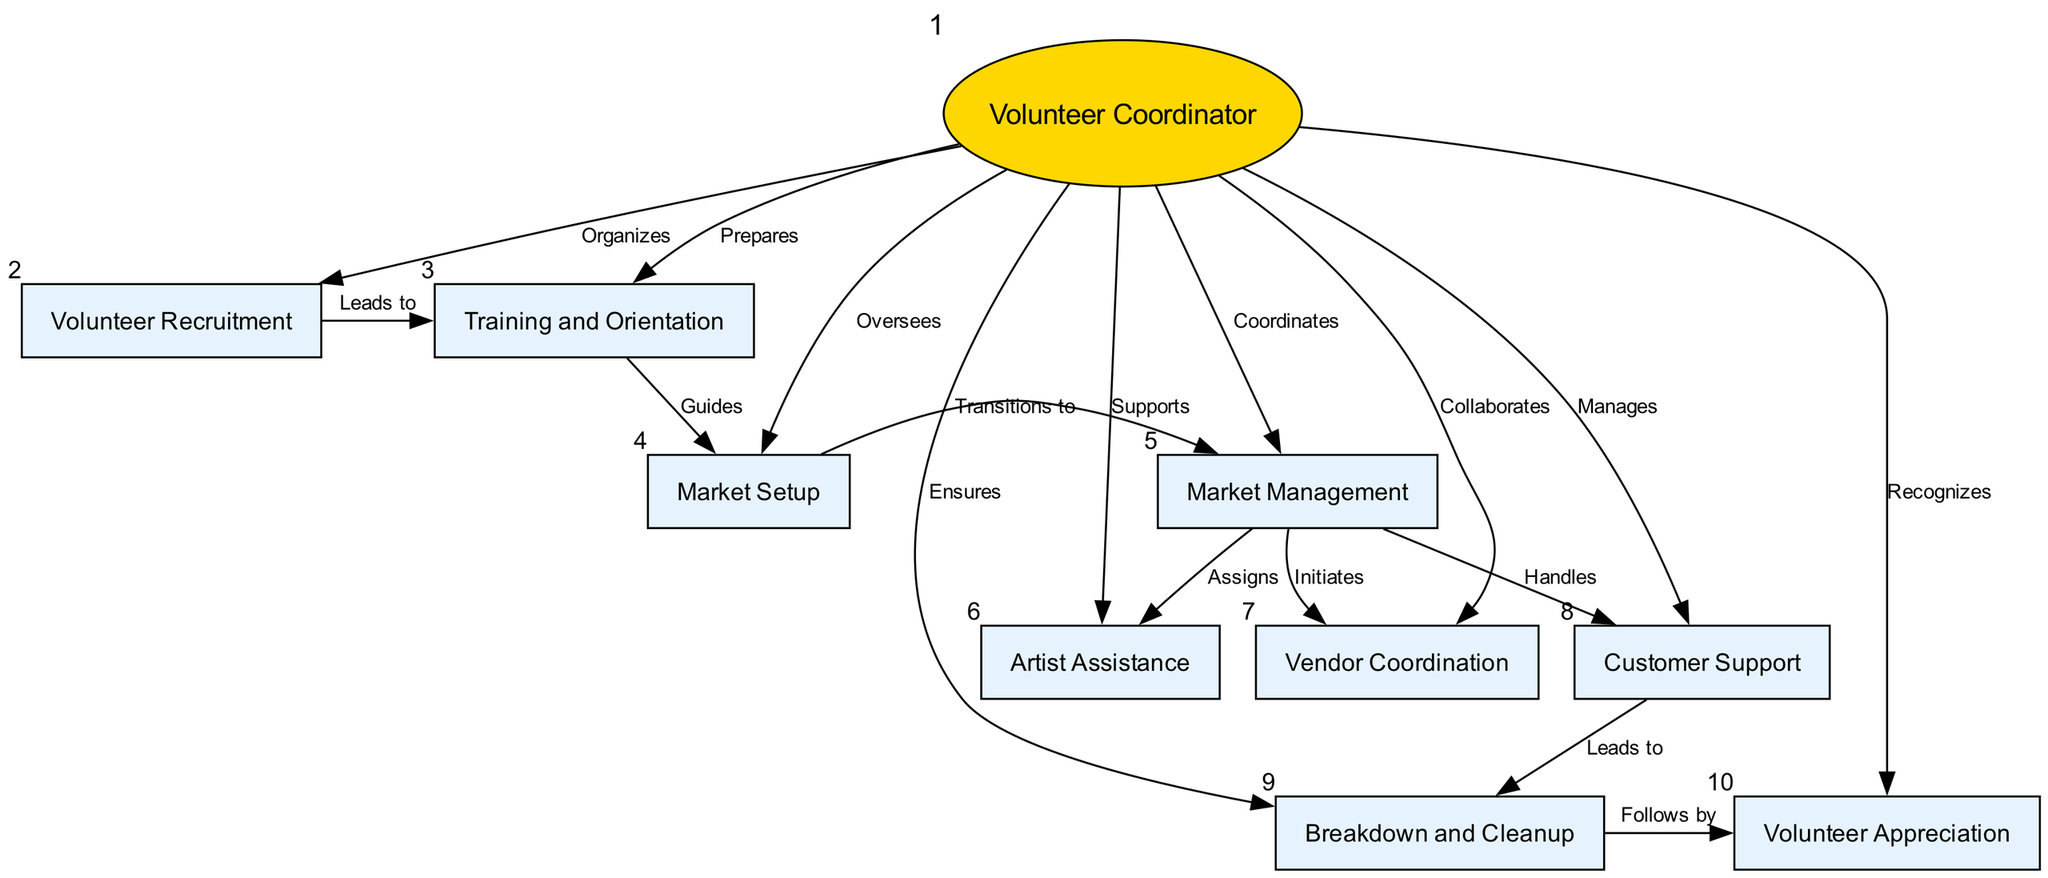What is the central node in the diagram? The central node is identified as the "Volunteer Coordinator" which is represented by a unique shape (ellipse) and highlighted differently from other nodes.
Answer: Volunteer Coordinator How many volunteer activities are listed in the diagram? By counting the nodes, there are ten volunteer activities represented in the diagram, which include both tasks and roles.
Answer: 10 Which activity is the Volunteer Coordinator responsible for overseeing? The "Market Setup" is directly linked to the Volunteer Coordinator with the edge labeled "Oversees," indicating their responsibility for this task.
Answer: Market Setup Which task follows "Customer Support" in the sequence? By following the directed flow from the "Customer Support" node, the next related node is "Breakdown and Cleanup," which is shown to be transitioned to by an edge labeled "Leads to."
Answer: Breakdown and Cleanup What does "Market Management" lead to in this diagram? The diagram shows that "Market Management" initiates three different activities based on the edges connected to it: "Artist Assistance," "Vendor Coordination," and "Customer Support."
Answer: Artist Assistance, Vendor Coordination, Customer Support How does "Volunteer Recruitment" relate to "Training and Orientation"? The diagram indicates a direct relationship where "Volunteer Recruitment" leads to "Training and Orientation," meaning that recruitment is the precursor to training.
Answer: Leads to What is a direct consequence of completing the "Breakdown and Cleanup"? The diagram indicates that after "Breakdown and Cleanup," the next step is "Volunteer Appreciation," connected by an edge labeled "Follows by."
Answer: Volunteer Appreciation What kind of support does the Volunteer Coordinator provide regarding artists? The relationship is shown as "Supports" which indicates the Volunteer Coordinator’s role in facilitating assistance for artists participating in the market.
Answer: Supports Which two activities come after "Market Setup"? Following the diagram's connections, "Market Setup" leads to "Market Management," which then transitions directly to "Artist Assistance," "Vendor Coordination," and "Customer Support."
Answer: Market Management, Artist Assistance, Vendor Coordination, Customer Support 